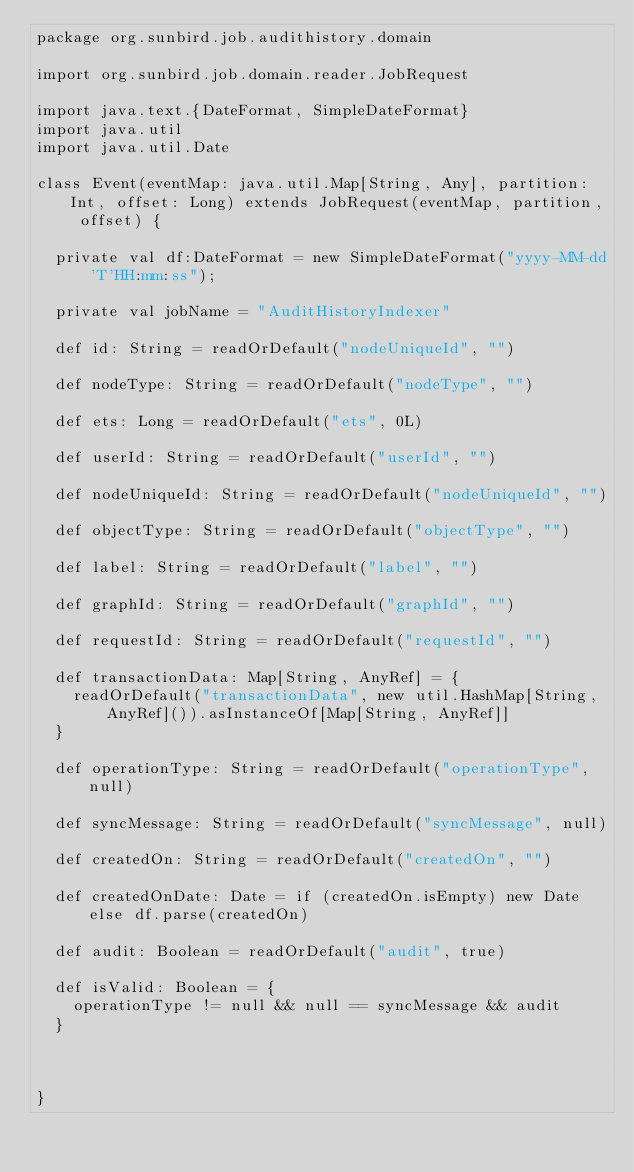Convert code to text. <code><loc_0><loc_0><loc_500><loc_500><_Scala_>package org.sunbird.job.audithistory.domain

import org.sunbird.job.domain.reader.JobRequest

import java.text.{DateFormat, SimpleDateFormat}
import java.util
import java.util.Date

class Event(eventMap: java.util.Map[String, Any], partition: Int, offset: Long) extends JobRequest(eventMap, partition, offset) {

  private val df:DateFormat = new SimpleDateFormat("yyyy-MM-dd'T'HH:mm:ss");

  private val jobName = "AuditHistoryIndexer"

  def id: String = readOrDefault("nodeUniqueId", "")

  def nodeType: String = readOrDefault("nodeType", "")

  def ets: Long = readOrDefault("ets", 0L)

  def userId: String = readOrDefault("userId", "")

  def nodeUniqueId: String = readOrDefault("nodeUniqueId", "")

  def objectType: String = readOrDefault("objectType", "")

  def label: String = readOrDefault("label", "")

  def graphId: String = readOrDefault("graphId", "")

  def requestId: String = readOrDefault("requestId", "")

  def transactionData: Map[String, AnyRef] = {
    readOrDefault("transactionData", new util.HashMap[String, AnyRef]()).asInstanceOf[Map[String, AnyRef]]
  }

  def operationType: String = readOrDefault("operationType", null)

  def syncMessage: String = readOrDefault("syncMessage", null)

  def createdOn: String = readOrDefault("createdOn", "")

  def createdOnDate: Date = if (createdOn.isEmpty) new Date else df.parse(createdOn)

  def audit: Boolean = readOrDefault("audit", true)

  def isValid: Boolean = {
    operationType != null && null == syncMessage && audit
  }



}
</code> 